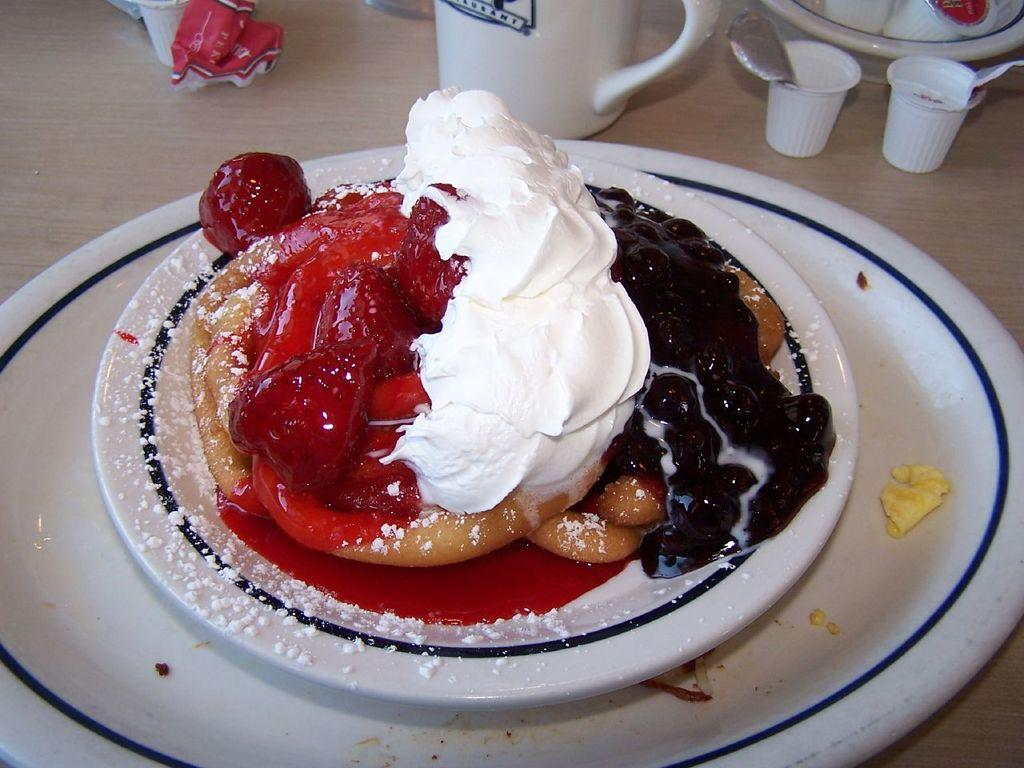What type of surface is visible in the image? There is a wooden surface in the image. What is placed on the wooden surface? There is a plate on the wooden surface. What is on the plate? There is food on the plate. How many cups are in the image? There are two cups in the image. What else can be seen in the image besides the wooden surface, plate, food, and cups? There are pots in the image. What type of apparel is being worn by the food in the image? There is no apparel present in the image, as the food is not a living being that can wear clothing. 